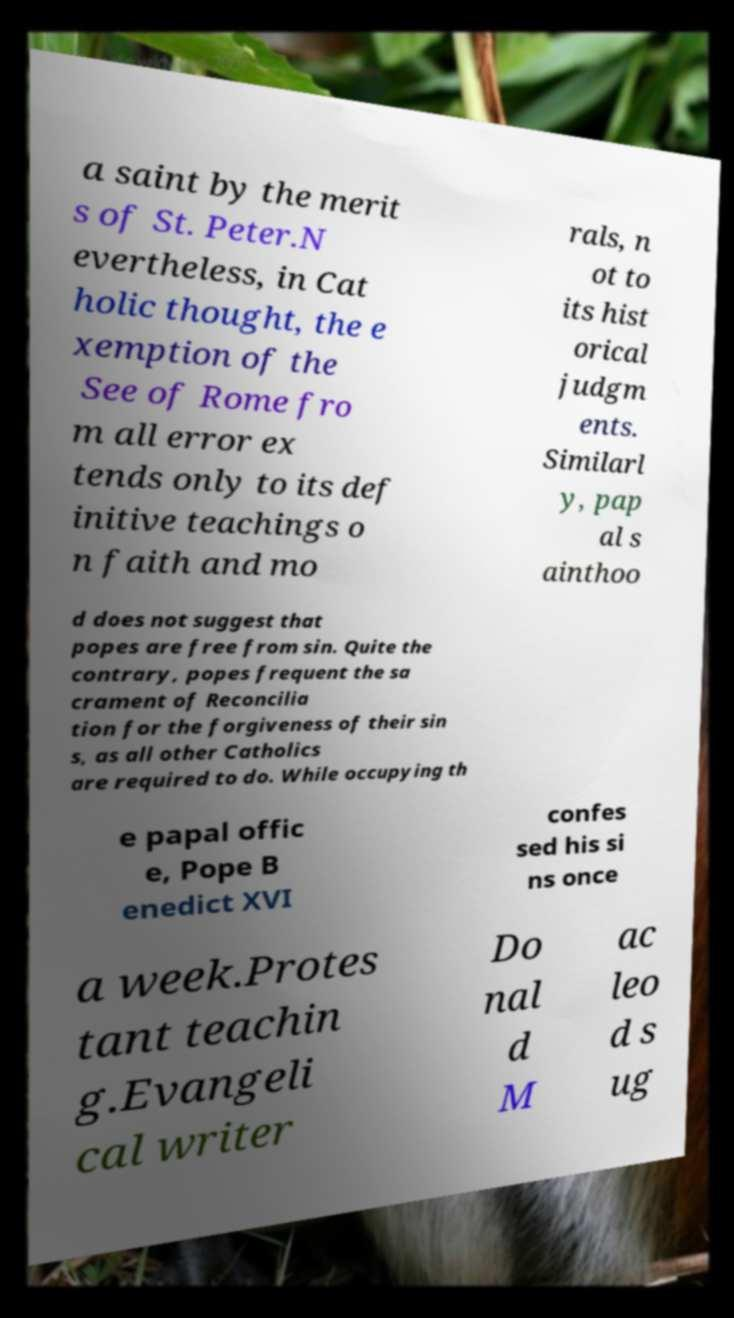Please read and relay the text visible in this image. What does it say? a saint by the merit s of St. Peter.N evertheless, in Cat holic thought, the e xemption of the See of Rome fro m all error ex tends only to its def initive teachings o n faith and mo rals, n ot to its hist orical judgm ents. Similarl y, pap al s ainthoo d does not suggest that popes are free from sin. Quite the contrary, popes frequent the sa crament of Reconcilia tion for the forgiveness of their sin s, as all other Catholics are required to do. While occupying th e papal offic e, Pope B enedict XVI confes sed his si ns once a week.Protes tant teachin g.Evangeli cal writer Do nal d M ac leo d s ug 